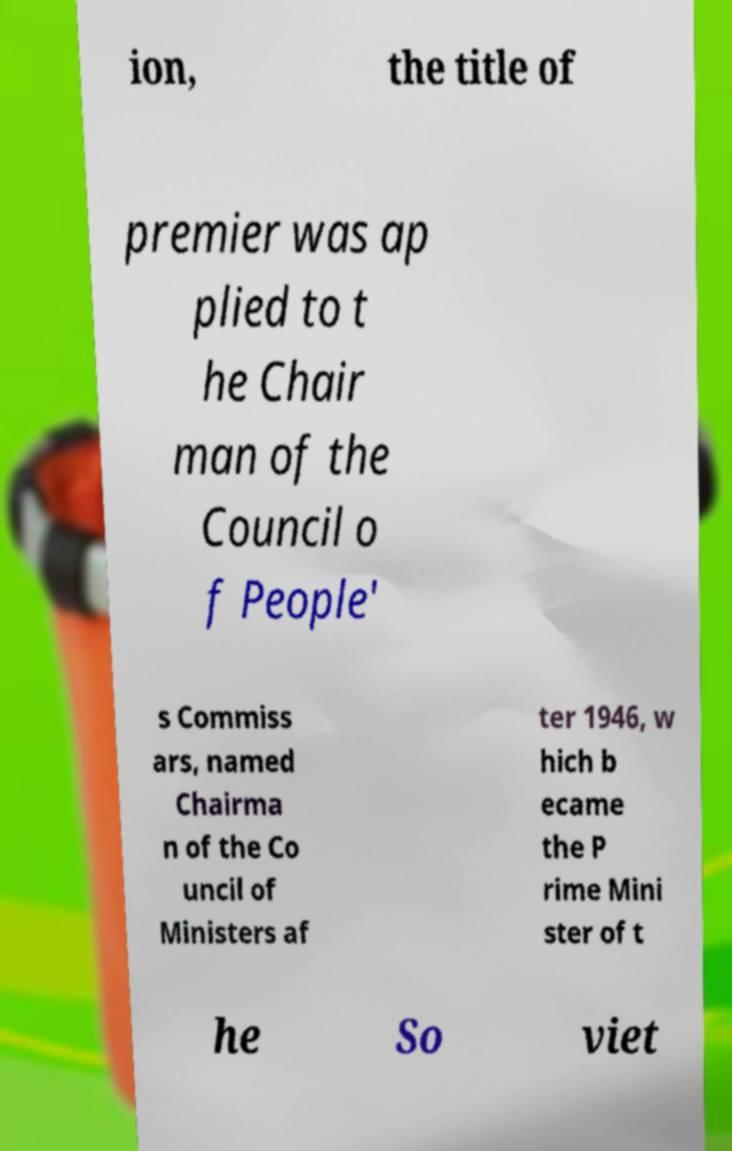Please identify and transcribe the text found in this image. ion, the title of premier was ap plied to t he Chair man of the Council o f People' s Commiss ars, named Chairma n of the Co uncil of Ministers af ter 1946, w hich b ecame the P rime Mini ster of t he So viet 